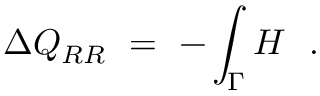Convert formula to latex. <formula><loc_0><loc_0><loc_500><loc_500>\Delta Q _ { R R } \ = \ - \int _ { \Gamma } H \ \ .</formula> 